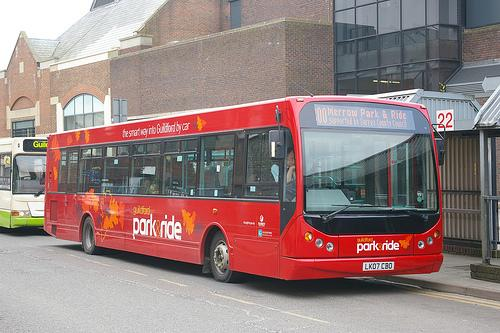What kind of road is the bus parked on, and what color is it? The bus is parked on a tarmacked road, and the color is grey. Analyze the interaction between the main object in the image and any nearby components. The red bus is parked near a sidewalk beside a bus stop, interacting with the infrastructure and environment of the city, including nearby buildings. Based on the information provided, is the front window of the bus clear or dirty? The front window of the bus is clear. In the image, how many visible buses are there, and what colors are they? There are two buses: one is red, and the other is white and light green. Describe the image's main components from a sentimental point of view. The image is filled with symbols of urban transportation and infrastructure, creating a sense of movement and connectivity. What's the number displayed on the bus stop, and what's written on the bus in the image? The number on the bus stop is 22, and there is writing displaying the bus company name on the side of the bus. Please provide a detailed description of the scene in the image. There is a large red bus parked on a tarmacked, grey road beside a bus stop, with windows closed, and behind it is a white and light green bus. A brick building is close by with large windows, and a bus stop sign displaying the number 22. Tell me the focus of the image in simple terms. A red bus parked on the side of a road. Count the number of windows associated with the bus in the image. There are at least four windows associated with the bus mentioned in the image. Take into account the quality of the image and the information provided, and judge the sharpness of its components. The image components seem to be sharp and clearly defined, such as the clear front window of the bus and the distinct color of the road. Is there a cat sitting on the sidewalk near the bus stop at X:450 Y:200 Width:20 Height:20? There is no mention of a cat or any animals in the image, and the given coordinates do not match any of the described objects. Is the bus stop sign blue with white letters at X:465 Y:75 Width:30 Height:30? While there is a bus stop sign mentioned, there is no mention of its color or the color of the text, and the given coordinates deviate slightly from the real object's position. Are there bicycles parked next to the red bus at X:410 Y:230 Width:60 Height:60? There are no mentions of bicycles present in the image, and the given coordinates do not match any of the described objects. Is the bus driver wearing a yellow hat at X:260 Y:135 Width:40 Height:40? While there is a bus driver mentioned, there is no mention of him wearing a hat, much less a yellow one. The given coordinates may slightly deviate from the bus driver's actual position as well. Can you find a tree with green leaves at X:300 Y:250 Width:80 Height:80? There is no mention of a tree or any vegetation in the image, and the given coordinates do not match any of the described objects. Is there a blue car in the corner of the image with X:250 Y:200 Width:100 Height:100? There is no mention of a blue car in the image, and the given coordinates do not match any of the described objects. 